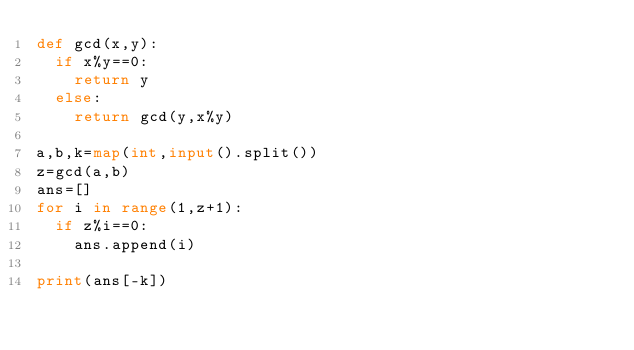Convert code to text. <code><loc_0><loc_0><loc_500><loc_500><_Python_>def gcd(x,y):
  if x%y==0:
    return y
  else:
    return gcd(y,x%y)

a,b,k=map(int,input().split())
z=gcd(a,b)
ans=[]
for i in range(1,z+1):
  if z%i==0:
    ans.append(i)
    
print(ans[-k])  
    
</code> 